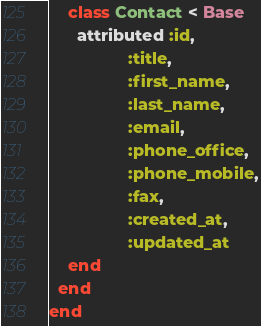Convert code to text. <code><loc_0><loc_0><loc_500><loc_500><_Ruby_>    class Contact < Base
      attributed :id,
                 :title,
                 :first_name,
                 :last_name,
                 :email,
                 :phone_office,
                 :phone_mobile,
                 :fax,
                 :created_at,
                 :updated_at
    end
  end
end
</code> 